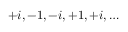Convert formula to latex. <formula><loc_0><loc_0><loc_500><loc_500>\, + i , - 1 , - i , + 1 , + i , \dots</formula> 